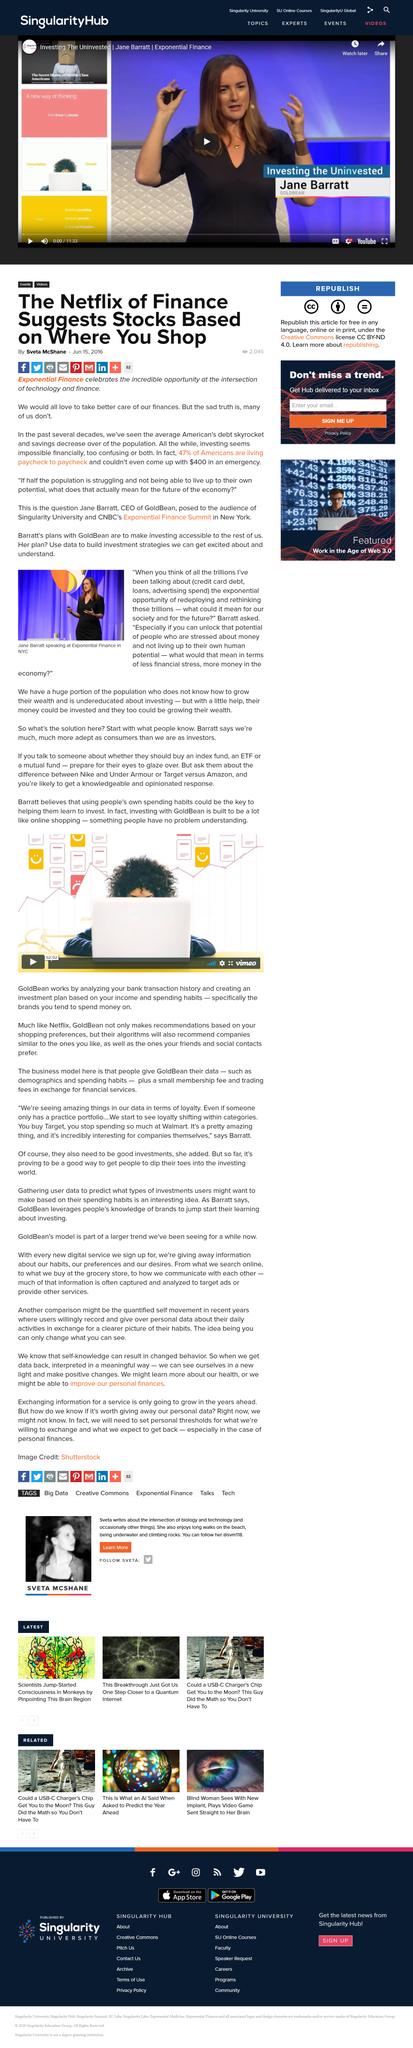Outline some significant characteristics in this image. GoldBean generates revenue by charging a small membership fee and trading fees for financial services provided to its customers. According to a recent survey, 47% of Americans are living paycheck to paycheck, struggling to make ends meet from one paycheck to the next. GoldBean is an AI investment advisor that creates personalized investment plans based on an individual's income and spending habits. It not only generates recommendations based on these preferences but also recommends companies that align with an individual's interests and the preferences of their social network. GoldBean aims to provide a seamless and personalized investment experience. GoldBear provides individuals with their personal data, including demographics and spending patterns, to help them better understand and manage their financial lives. Barratt states that we are more adept as consumers rather than investors. 